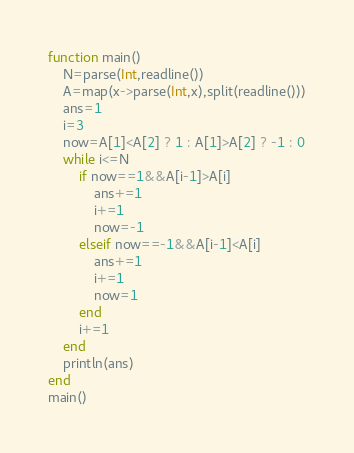<code> <loc_0><loc_0><loc_500><loc_500><_Julia_>function main()
	N=parse(Int,readline())
	A=map(x->parse(Int,x),split(readline()))
	ans=1
	i=3
	now=A[1]<A[2] ? 1 : A[1]>A[2] ? -1 : 0
	while i<=N
		if now==1&&A[i-1]>A[i]
			ans+=1
			i+=1
			now=-1
		elseif now==-1&&A[i-1]<A[i]
			ans+=1
			i+=1
			now=1
		end
		i+=1
	end
	println(ans)
end
main()</code> 